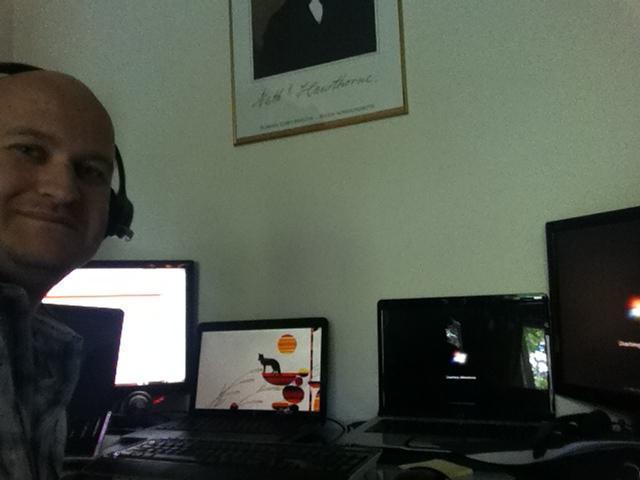What was installed on both the computers?
Answer the question by selecting the correct answer among the 4 following choices and explain your choice with a short sentence. The answer should be formatted with the following format: `Answer: choice
Rationale: rationale.`
Options: Windows, solaris, linux, osx. Answer: windows.
Rationale: Windows software is installed. 